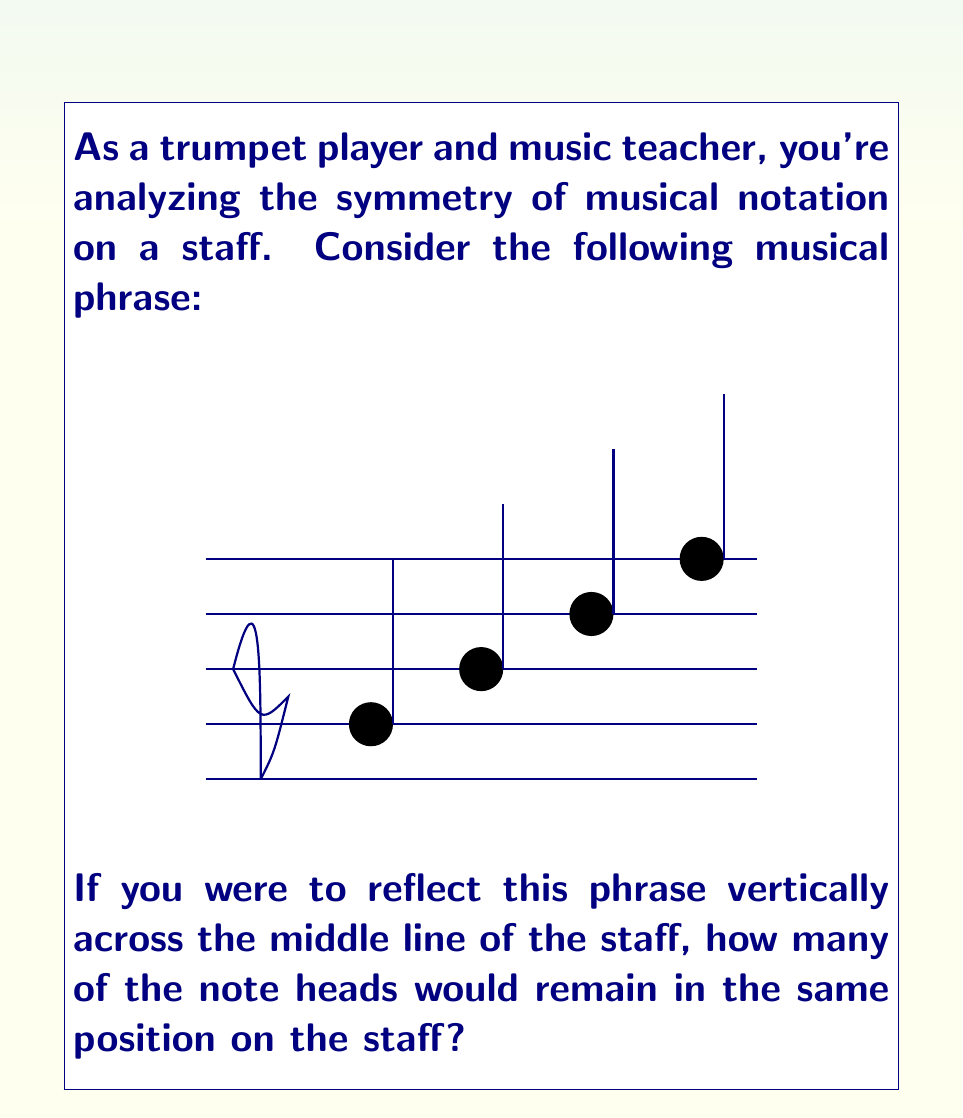Solve this math problem. Let's approach this step-by-step:

1) First, we need to identify the middle line of the staff. In a standard 5-line staff, the middle line is the 3rd line from the bottom.

2) Now, let's analyze each note's position relative to this middle line:
   - The first note is on the first line (2 lines below the middle)
   - The second note is on the second line (1 line below the middle)
   - The third note is on the third line (on the middle line)
   - The fourth note is on the fourth line (1 line above the middle)

3) If we reflect these notes across the middle line:
   - The first note would move to 2 lines above the middle (5th line)
   - The second note would move to 1 line above the middle (4th line)
   - The third note would stay on the middle line (3rd line)
   - The fourth note would move to 1 line below the middle (2nd line)

4) Comparing the original and reflected positions:
   - The first note changes position
   - The second note changes position
   - The third note remains in the same position
   - The fourth note changes position

5) Therefore, only one note (the third note) would remain in the same position after reflection.

This problem demonstrates the concept of reflection symmetry in musical notation, which is crucial for understanding transposition and harmonic relationships in music theory.
Answer: 1 